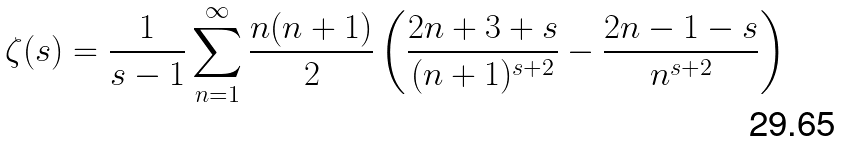<formula> <loc_0><loc_0><loc_500><loc_500>\zeta ( s ) = { \frac { 1 } { s - 1 } } \sum _ { n = 1 } ^ { \infty } { \frac { n ( n + 1 ) } { 2 } } \left ( { \frac { 2 n + 3 + s } { ( n + 1 ) ^ { s + 2 } } } - { \frac { 2 n - 1 - s } { n ^ { s + 2 } } } \right )</formula> 